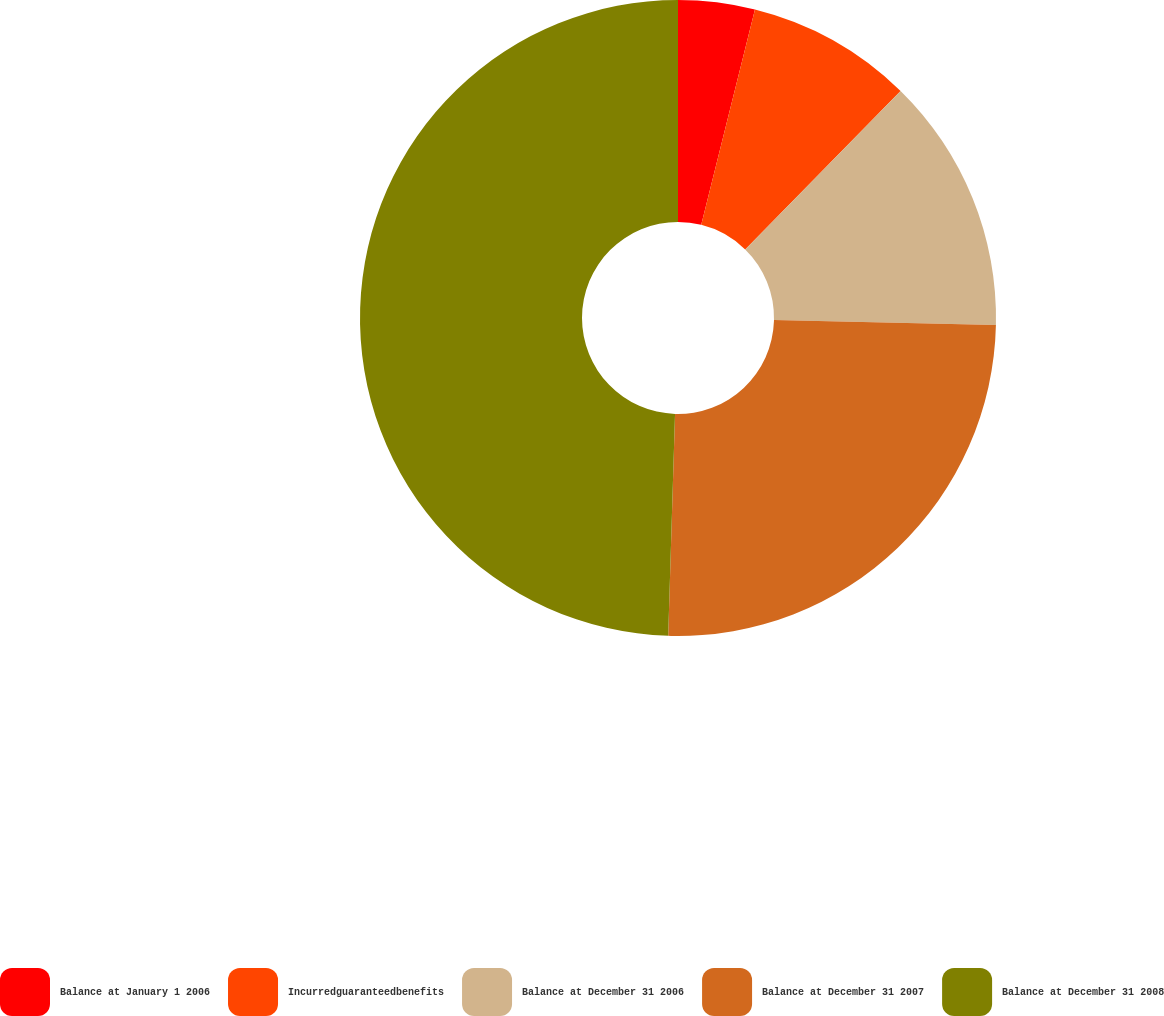Convert chart. <chart><loc_0><loc_0><loc_500><loc_500><pie_chart><fcel>Balance at January 1 2006<fcel>Incurredguaranteedbenefits<fcel>Balance at December 31 2006<fcel>Balance at December 31 2007<fcel>Balance at December 31 2008<nl><fcel>3.89%<fcel>8.45%<fcel>13.01%<fcel>25.14%<fcel>49.51%<nl></chart> 